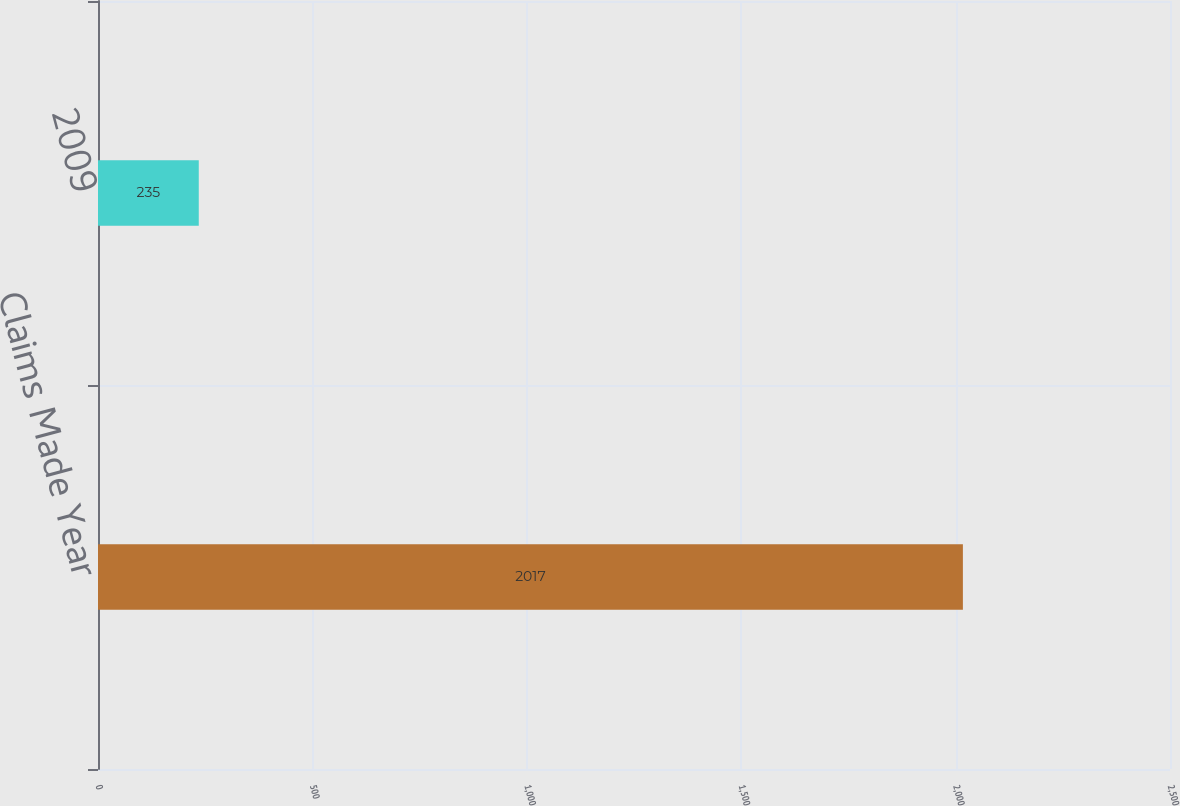<chart> <loc_0><loc_0><loc_500><loc_500><bar_chart><fcel>Claims Made Year<fcel>2009<nl><fcel>2017<fcel>235<nl></chart> 